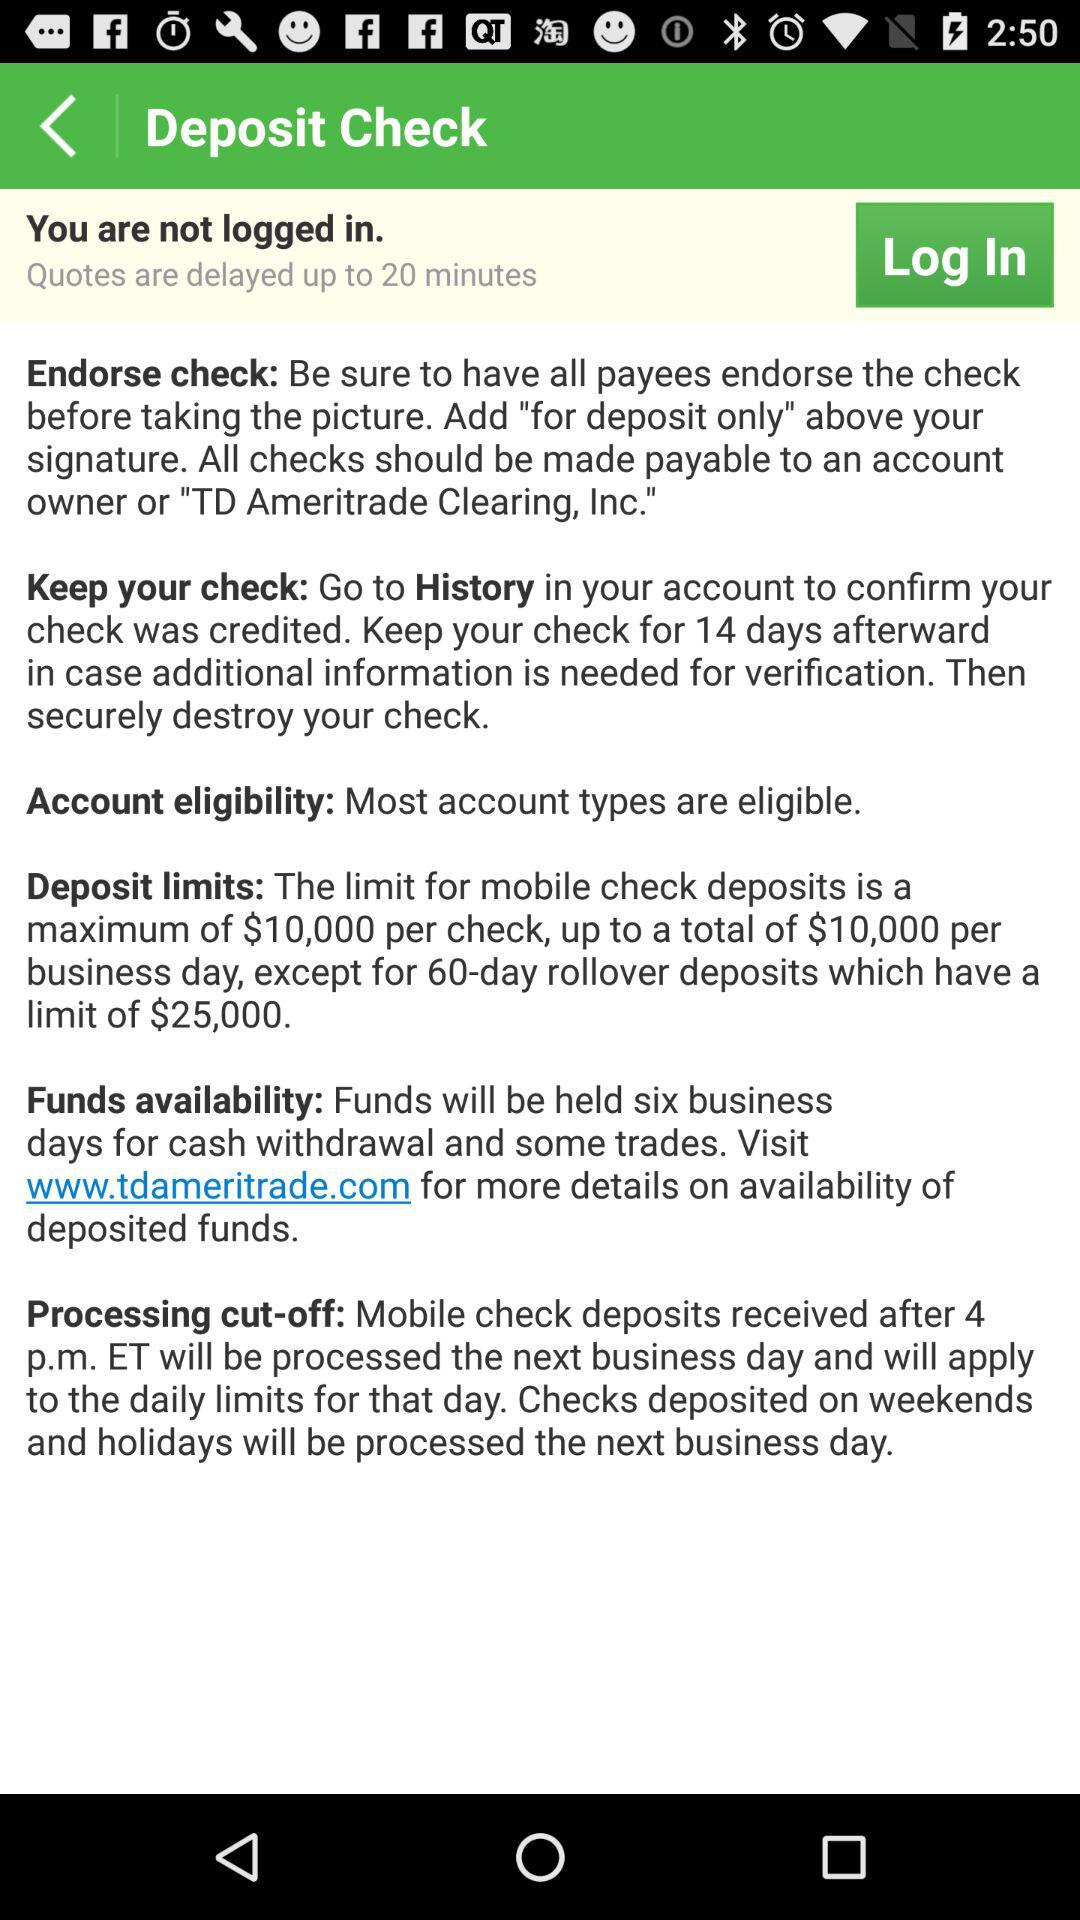How long will it take for funds to be available for withdrawal after depositing a check?
Answer the question using a single word or phrase. Six business days 